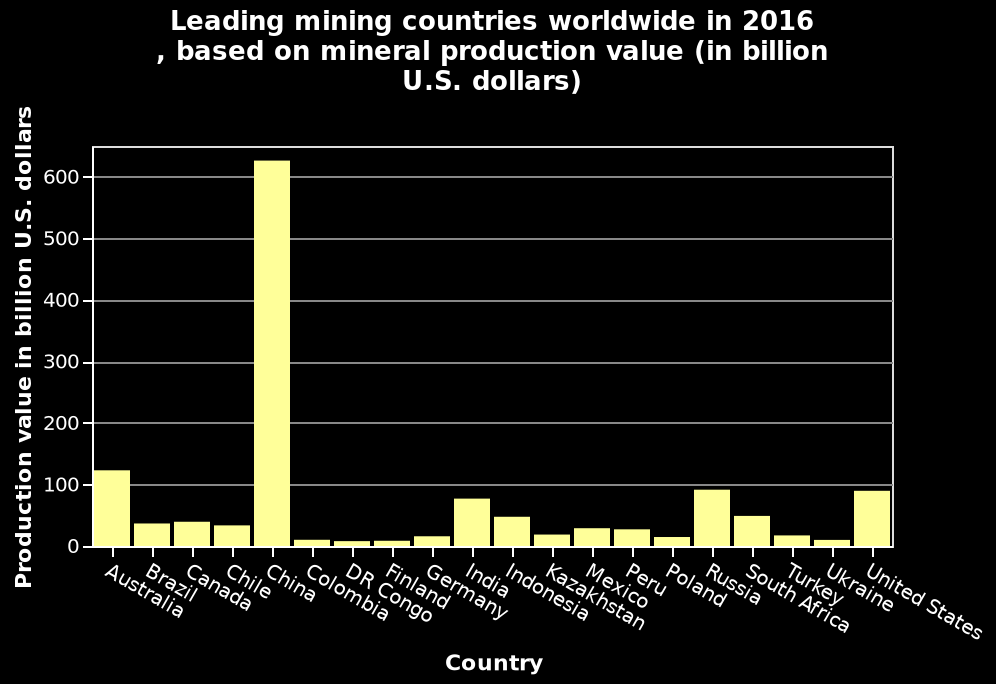<image>
please enumerates aspects of the construction of the chart This bar chart is named Leading mining countries worldwide in 2016 , based on mineral production value (in billion U.S. dollars). The y-axis measures Production value in billion U.S. dollars using linear scale with a minimum of 0 and a maximum of 600 while the x-axis plots Country on categorical scale starting with Australia and ending with United States. Offer a thorough analysis of the image. China was the leading mining country in 2016, with a production value of over 600 billion US dollars. China's mineral production dwarfed each of its nearest competitors Australia, India, Russia and the US by over 6 fold. 